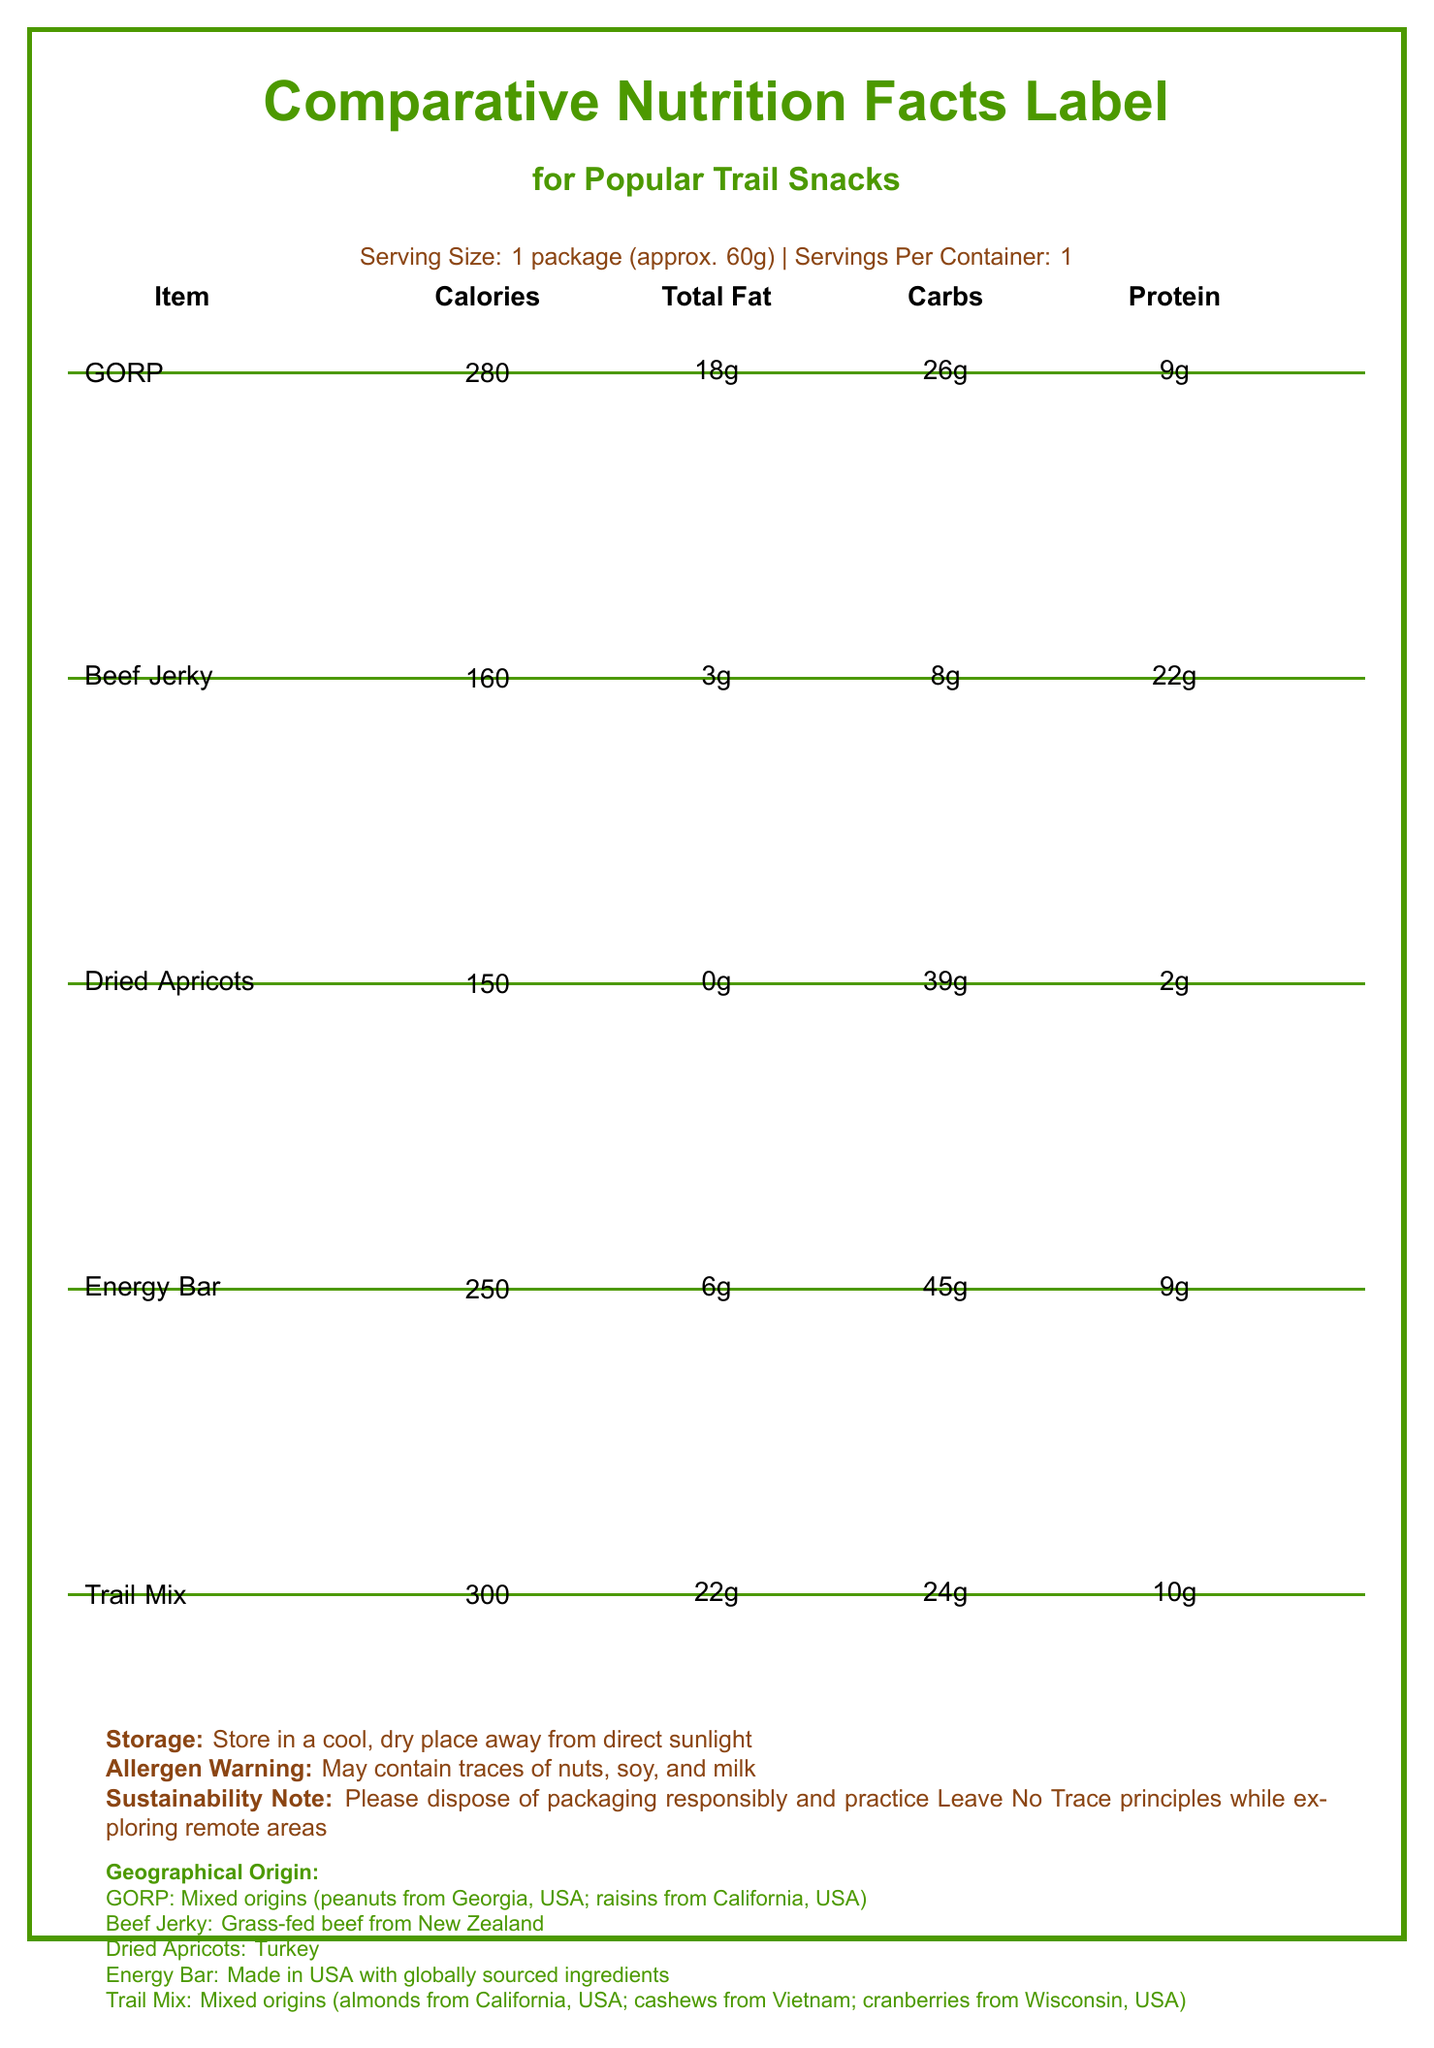what is the serving size for the trail snacks? The serving size is indicated at the top of the document under "Comparative Nutrition Facts Label for Popular Trail Snacks."
Answer: 1 package (approx. 60g) which trail snack has the highest calorie content? A. GORP B. Beef Jerky C. Dried Apricots D. Energy Bar E. Trail Mix Comparing the calorie content, Trail Mix has 300 calories which is the highest among the listed snacks.
Answer: E. Trail Mix does the beef jerky contain any cholesterol? The nutritional data for Beef Jerky shows it contains 35 mg of cholesterol.
Answer: Yes which snack contains the most dietary fiber? According to the document, both the Energy Bar and Dried Apricots have 5g of dietary fiber.
Answer: Energy Bar and Dried Apricots where are the raisins in GORP sourced from? The geographical origin section indicates that the raisins in GORP are from California, USA.
Answer: California, USA which snack is traditionally known among Appalachian Trail hikers since the 1960s? A. GORP B. Beef Jerky C. Dried Apricots D. Energy Bar E. Trail Mix The cultural significance section mentions that GORP has been popular among Appalachian Trail hikers since the 1960s.
Answer: A. GORP is it recommended to store these trail snacks in direct sunlight? The storage instructions advise to store in a cool, dry place away from direct sunlight.
Answer: No what is the total carbohydrate content in the Energy Bar? Under the nutritional details, the Energy Bar has a total carbohydrate content of 45g.
Answer: 45g describe the main idea of the document The document is focused on providing a comprehensive comparison of nutritional information and contextual background for various trail snacks, aiming to help hikers make informed choices.
Answer: This document presents a comparative nutrition facts label for popular trail snacks, including GORP, Beef Jerky, Dried Apricots, an Energy Bar, and Trail Mix. It includes details on serving size, calorie content, and nutritional breakdown such as fats, carbohydrates, and protein. Additional information includes storage advice, allergens, sustainability notes, geographical origin, and cultural significance of the snacks. which snack has the least amount of sodium? A. GORP B. Beef Jerky C. Dried Apricots D. Energy Bar E. Trail Mix Dried Apricots have the least amount of sodium, with only 10 mg.
Answer: C. Dried Apricots how much protein does the Trail Mix contain? The protein content for Trail Mix is listed as 10g in the document.
Answer: 10g where is the grass-fed beef in Beef Jerky sourced from? The geographical origin section specifies that the grass-fed beef in Beef Jerky is from New Zealand.
Answer: New Zealand what is the sustainability note mentioned in the document? The sustainability note advises responsible disposal of packaging and adherence to Leave No Trace principles.
Answer: Please dispose of packaging responsibly and practice Leave No Trace principles while exploring remote areas which snack has the highest potassium content? The document shows that Dried Apricots have the highest potassium content, with 680 mg.
Answer: Dried Apricots what is the saturated fat content in the Trail Mix? The Trail Mix has a saturated fat content of 4g.
Answer: 4g how much calcium does the Energy Bar provide? The nutritional information for the Energy Bar shows it contains 100mg of calcium.
Answer: 100mg are there any snacks without trans fat listed? All the listed snacks (GORP, Beef Jerky, Dried Apricots, Energy Bar, and Trail Mix) show 0g of trans fat.
Answer: Yes how many grams of dietary fiber are in Beef Jerky? The nutritional facts for Beef Jerky indicate that it has 0g of dietary fiber.
Answer: 0g do the listed snacks contain any vitamin D? Each snack's nutritional data shows 0g of vitamin D.
Answer: No how many total sugars are present in GORP? The total sugar content in GORP is listed as 18g.
Answer: 18g how much total fat is in Beef Jerky? Beef Jerky contains 3g of total fat according to the nutritional information.
Answer: 3g which snack contains cashews from Vietnam? The geographical origin section mentions that the Trail Mix contains cashews from Vietnam.
Answer: Trail Mix how much iron is present in all the snacks? Each snack listed in the document contains 2mg of iron.
Answer: 2mg what type of nuts are included in the GORP? The document specifies that GORP contains peanuts sourced from Georgia, USA.
Answer: Peanuts which trail snack is described as a modern invention catering to endurance athletes? A. GORP B. Beef Jerky C. Dried Apricots D. Energy Bar E. Trail Mix The cultural significance section states that the Energy Bar is a modern invention made for endurance athletes and outdoor enthusiasts.
Answer: D. Energy Bar how many servings per container for the snacks? The serving size information denotes that there is 1 serving per container for each snack.
Answer: 1 which trail snack has the lowest calories? Dried Apricots have the lowest calorie content at 150 calories.
Answer: Dried Apricots what does the allergen warning indicate? The allergen warning advises that the snacks may contain traces of nuts, soy, and milk.
Answer: May contain traces of nuts, soy, and milk which snack is described as a staple food along the Silk Road? The cultural significance section notes that Dried Apricots were a staple food along the ancient Silk Road trading routes.
Answer: Dried Apricots which snack became popular among surfers in California during the 1960s? The cultural significance information indicates that Trail Mix was popularized by surfers in California in the 1960s.
Answer: Trail Mix where are the almonds in the Trail Mix from? The geographical origin section mentions that the almonds in the Trail Mix are sourced from California, USA.
Answer: California, USA does the document mention the specific types of sugars in the Energy Bar? The document lists total sugars but does not specify the types of sugars in the Energy Bar.
Answer: Cannot be determined 